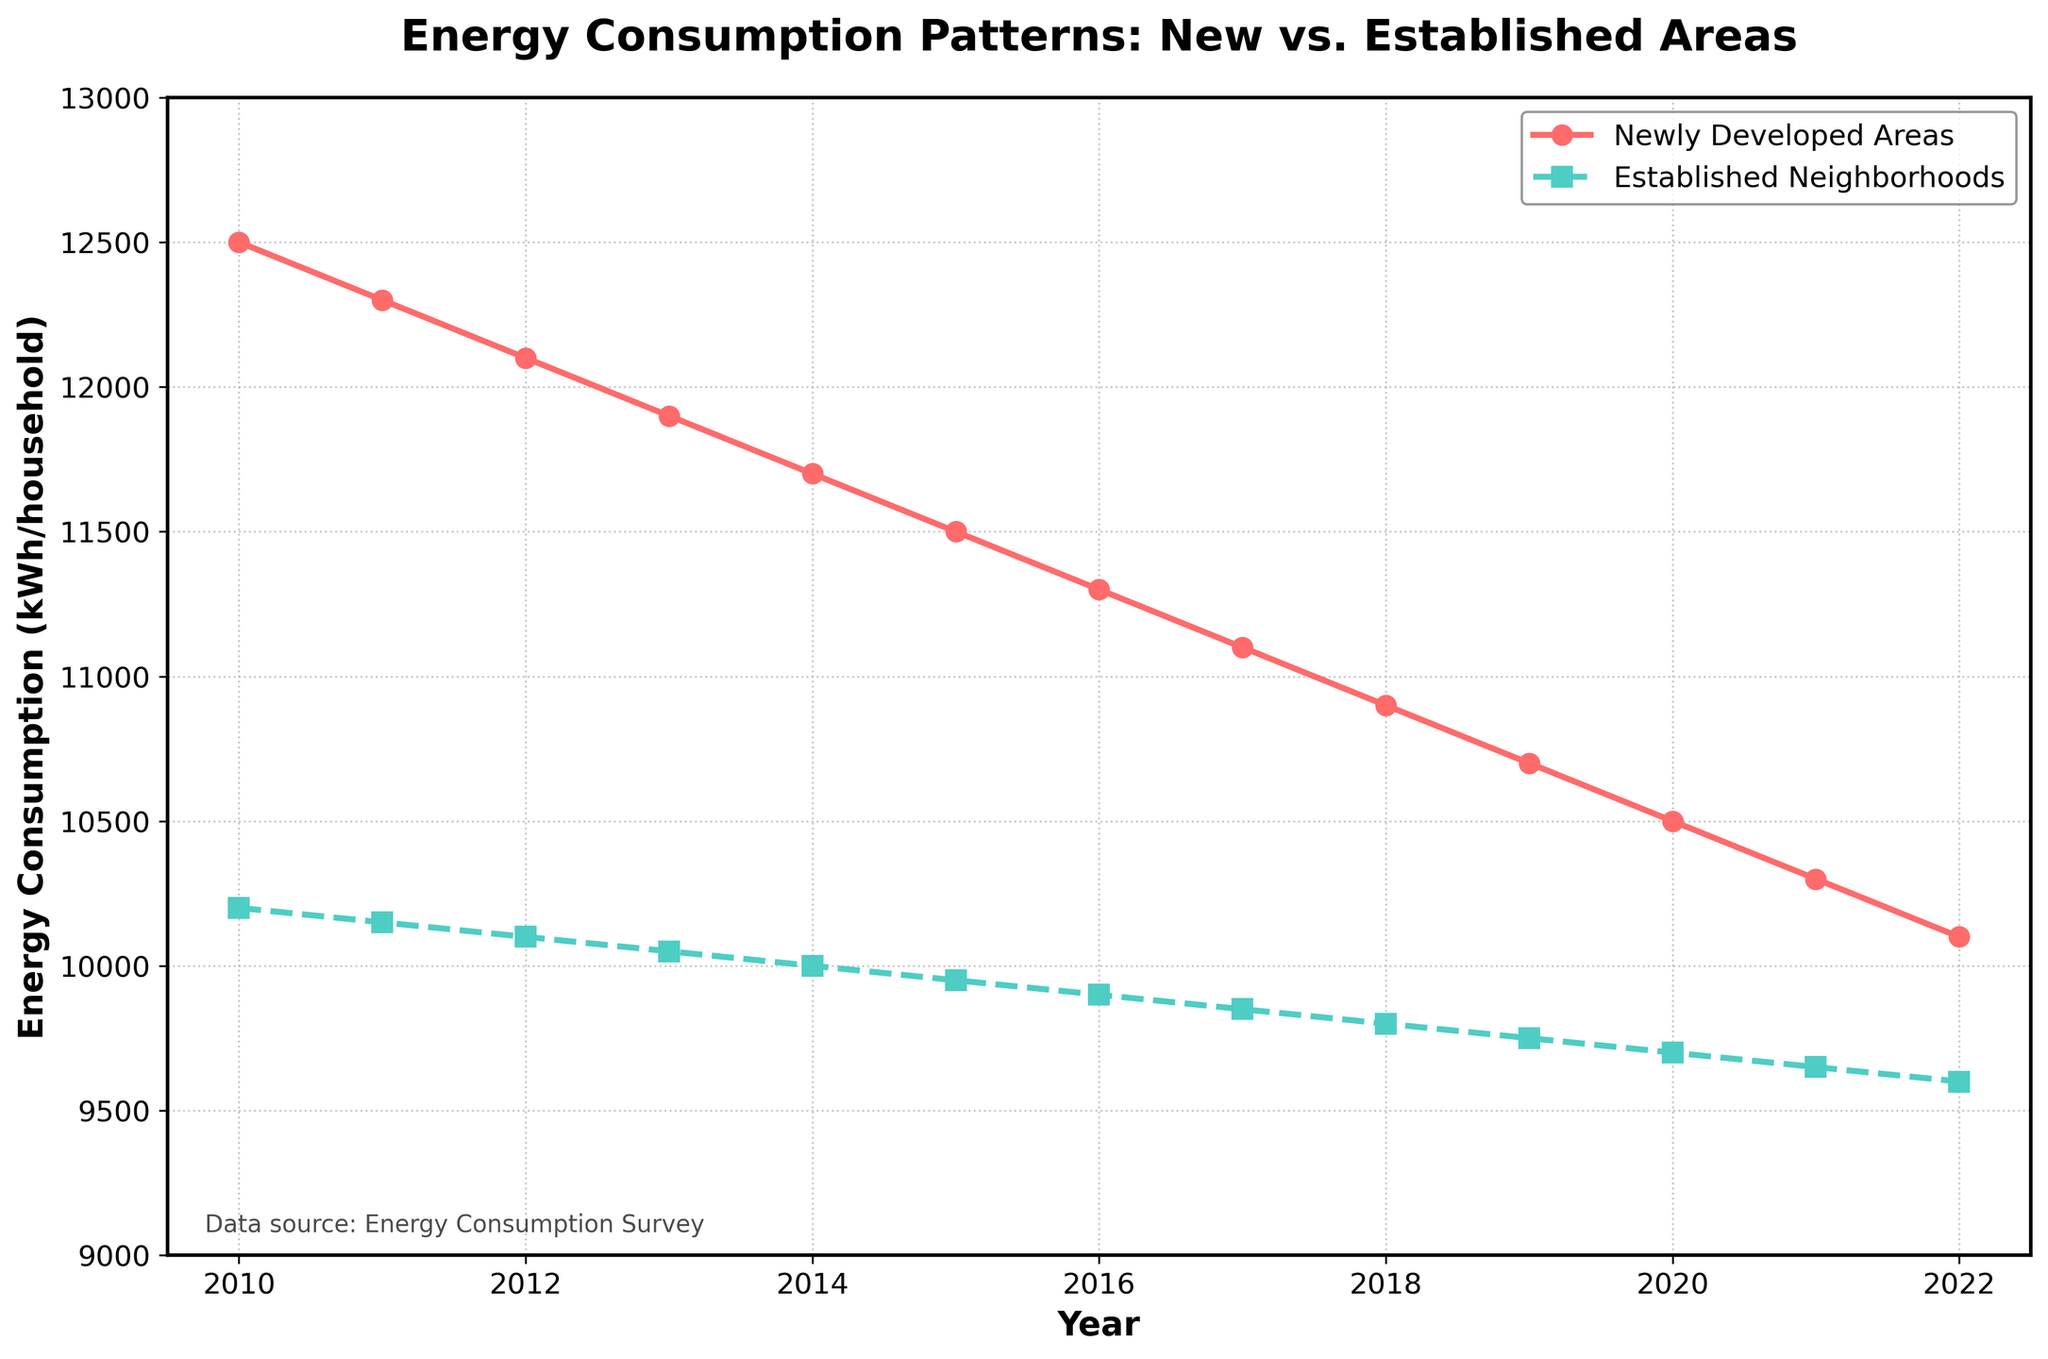What is the general trend of energy consumption in newly developed areas from 2010 to 2022? The energy consumption in newly developed areas shows a decreasing trend from 2010 to 2022. In 2010, it starts at 12,500 kWh per household, and it decreases every year, reaching 10,100 kWh per household in 2022.
Answer: Decreasing Which year had the smallest difference in energy consumption between newly developed areas and established neighborhoods? To find the smallest difference, we calculate the absolute difference for each year. The differences are: 2300, 2150, 2000, 1850, 1700, 1550, 1400, 1250, 1100, 950, 800, 650, and 500. The smallest difference is in 2022, which is 500 kWh/household.
Answer: 2022 By how much did the energy consumption decrease in newly developed areas from 2010 to 2022? Subtract the value in the final year from the initial year for newly developed areas: 12,500 kWh - 10,100 kWh = 2,400 kWh.
Answer: 2,400 kWh In which year did established neighborhoods see energy consumption drop below 10,000 kWh/household? Reviewing the values for established neighborhoods, energy consumption dropped below 10,000 kWh/household in 2014, when it was 10,000 kWh/household. In 2015, it dropped to 9,950 kWh/household.
Answer: 2015 How did the energy consumption in newly developed areas change from 2011 to 2021? In 2011, the energy consumption was 12,300 kWh/household, and it changed to 10,300 kWh/household by 2021. This change is calculated as 12,300 - 10,300 = 2,000 kWh/household decrease.
Answer: Decreased by 2,000 kWh/household Compare the slope of the energy consumption trends between newly developed areas and established neighborhoods. Which area shows a steeper decline? To compare the slopes, look at the rate of decrease over the same period. Newly developed areas decreased by 2,400 kWh over 13 years, and established neighborhoods by 600 kWh. The slope for newly developed areas is steeper.
Answer: Newly developed areas What is the average energy consumption for established neighborhoods from 2010 to 2022? Sum the energy consumption values for established neighborhoods from 2010 to 2022 and divide by the number of years: (10200 + 10150 + 10100 + 10050 + 10000 + 9950 + 9900 + 9850 + 9800 + 9750 + 9700 + 9650 + 9600)/13 = 9925.
Answer: 9925 kWh/household What visual attribute differentiates the energy consumption trends of newly developed areas from established neighborhoods? The line for newly developed areas is shown in red with circular markers and continuous solid line, whereas the line for established neighborhoods is shown in green with square markers and a dashed line.
Answer: Color and line style During which period did both newly developed areas and established neighborhoods exhibit the same decreasing rate of energy consumption? Both areas show a consistent downward trend over the entire period. However, to identify the exact matching period with the same slope, compare particular segments. Both exhibit a consistent decreasing trend without visible anomalies year over year.
Answer: Entire period Between 2010 and 2022, which area had energy consumption closer to 10,000 kWh/household more often? Reviewing the data, established neighborhoods consistently have values closer to 10,000 kWh/household with values starting near 10,200 kWh and approaching 9,600 kWh. Newly developed areas start significantly higher and only approach this value toward the end of the period.
Answer: Established neighborhoods 